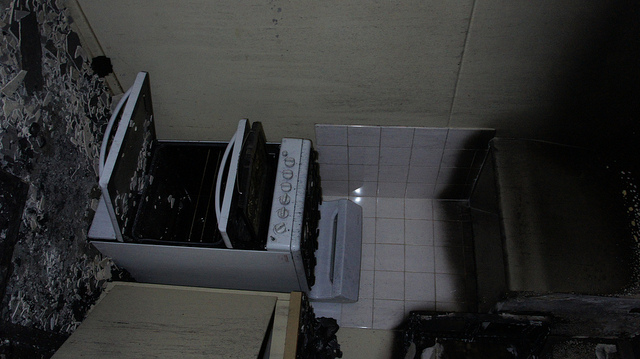<image>Which boat has water in the bottom? There is no boat with water in the bottom in the image. What is the metal object on the lower right called? It is unclear what the metal object on the lower right is called. However, it could be a cabinet, fridge, oven, exhaust, stove, or tv. Which boat has water in the bottom? There is no boat in the image that has water in the bottom. What is the metal object on the lower right called? I don't know what is the metal object on the lower right called. It can be either a cabinet, fridge, oven, exhaust, stove, or TV. 